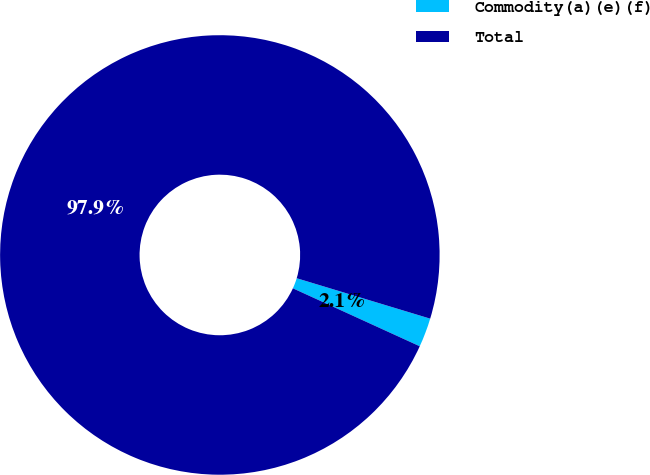Convert chart. <chart><loc_0><loc_0><loc_500><loc_500><pie_chart><fcel>Commodity(a)(e)(f)<fcel>Total<nl><fcel>2.14%<fcel>97.86%<nl></chart> 